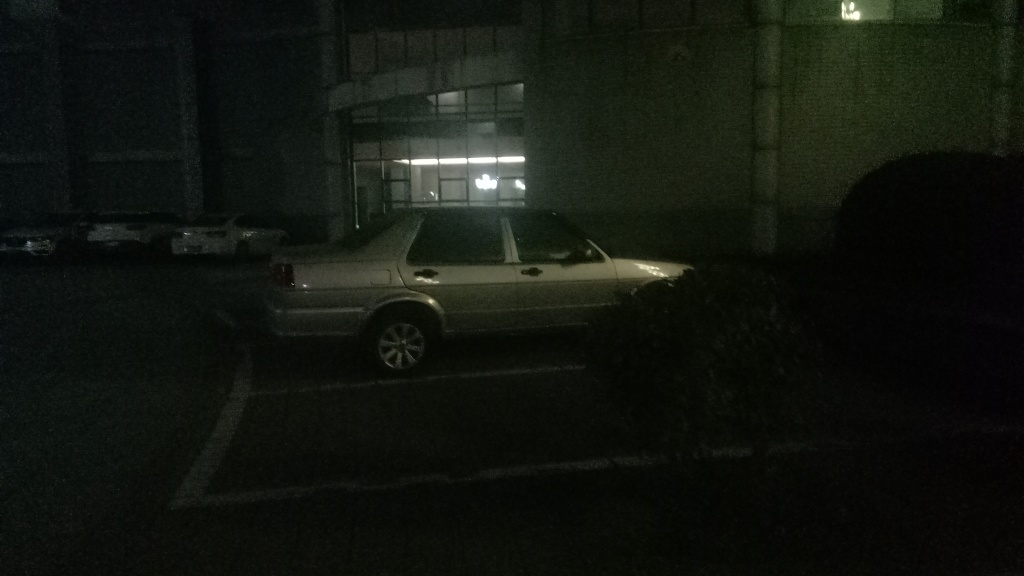Can you describe what's visible in this dimly lit image? In the image, there appears to be a car parked in an outdoor area with very low light, presumably during nighttime. The vehicle is likely silver in color and is parked next to a small bush or shrub. Details are hard to make out due to the poor lighting conditions. 